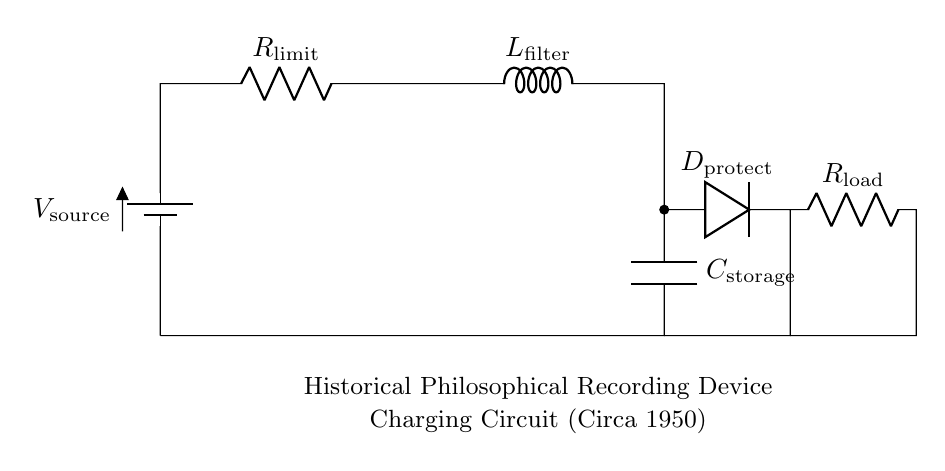What is the source voltage in the circuit? The source voltage is indicated as the variable V_source at the top of the circuit diagram.
Answer: V_source What component limits the charging current? The component that limits the charging current is labeled as R_limit in the circuit, which is a resistor responsible for controlling current flow.
Answer: R_limit What is the purpose of the diode in this circuit? The diode D_protect is used for protection against reverse polarity to prevent damage to the circuit components. It ensures current flows in only one direction.
Answer: Protection How many components are present in the charging path? The charging path includes five main components: the battery, resistor, inductor, capacitor, and diode, which means there are a total of five components in series.
Answer: Five What role does the inductor play in this charging circuit? The inductor L_filter smooths the current flowing into the capacitor, reducing voltage spikes and providing a stable current during charging.
Answer: Filtering What is the essential function of the capacitor in this circuit? The capacitor C_storage stores electrical energy during the charging process and releases it when needed in the circuit as the charge builds up.
Answer: Storage What is the load resistance in this circuit? The load resistance is indicated as R_load, which is usually the component connected to consume the stored energy in the capacitor.
Answer: R_load 